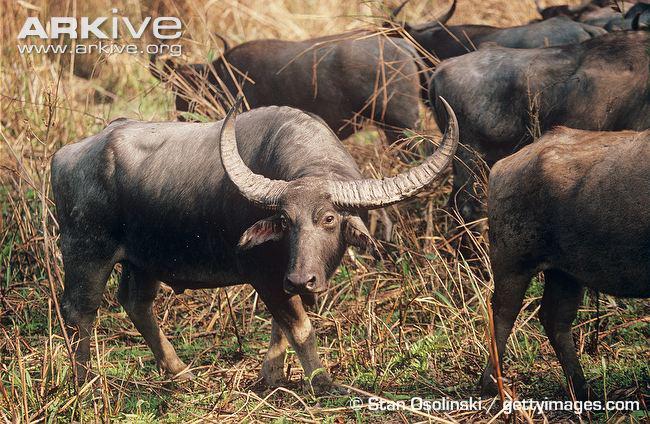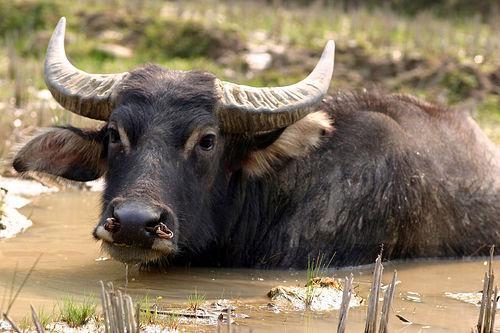The first image is the image on the left, the second image is the image on the right. For the images shown, is this caption "One of the images contains more than one water buffalo." true? Answer yes or no. Yes. 